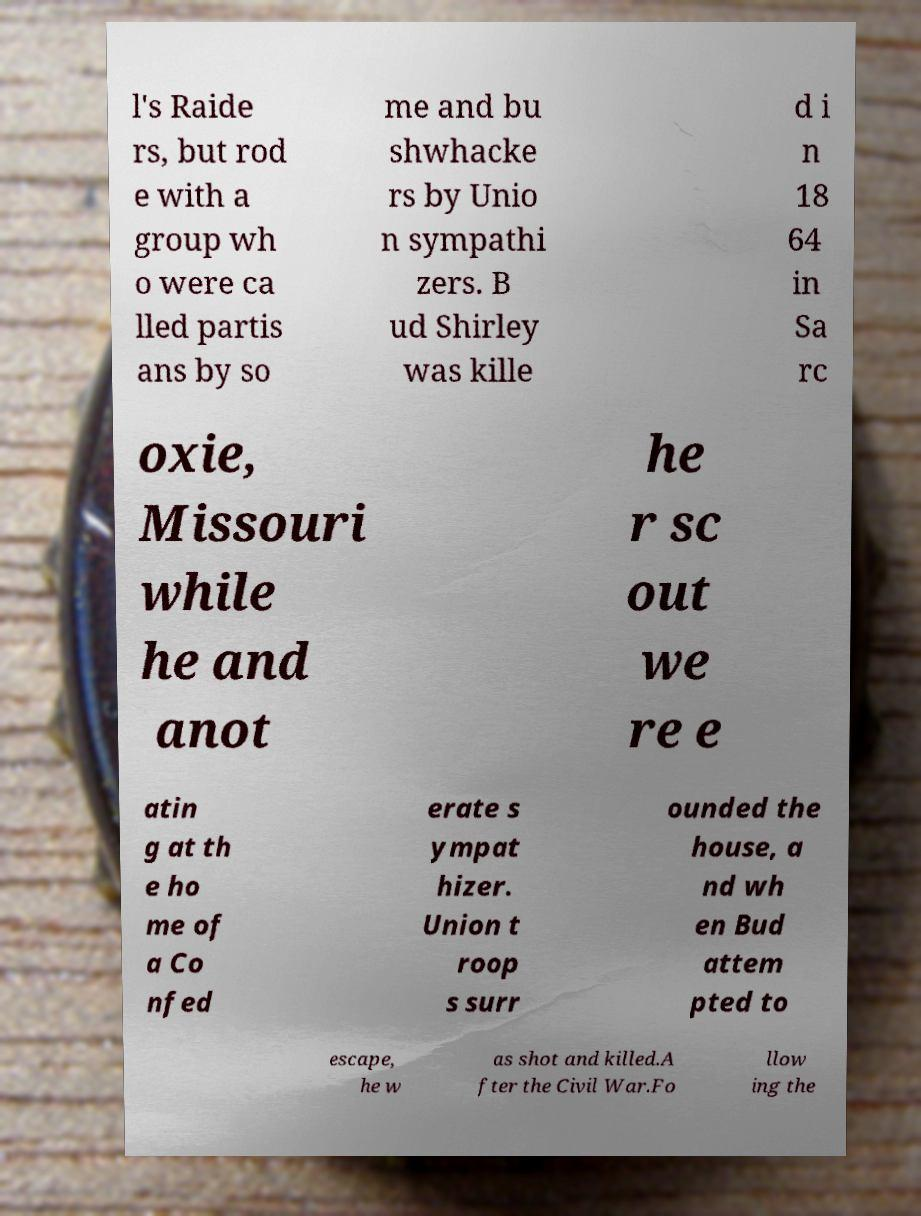There's text embedded in this image that I need extracted. Can you transcribe it verbatim? l's Raide rs, but rod e with a group wh o were ca lled partis ans by so me and bu shwhacke rs by Unio n sympathi zers. B ud Shirley was kille d i n 18 64 in Sa rc oxie, Missouri while he and anot he r sc out we re e atin g at th e ho me of a Co nfed erate s ympat hizer. Union t roop s surr ounded the house, a nd wh en Bud attem pted to escape, he w as shot and killed.A fter the Civil War.Fo llow ing the 